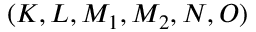<formula> <loc_0><loc_0><loc_500><loc_500>( K , L , M _ { 1 } , M _ { 2 } , N , O )</formula> 